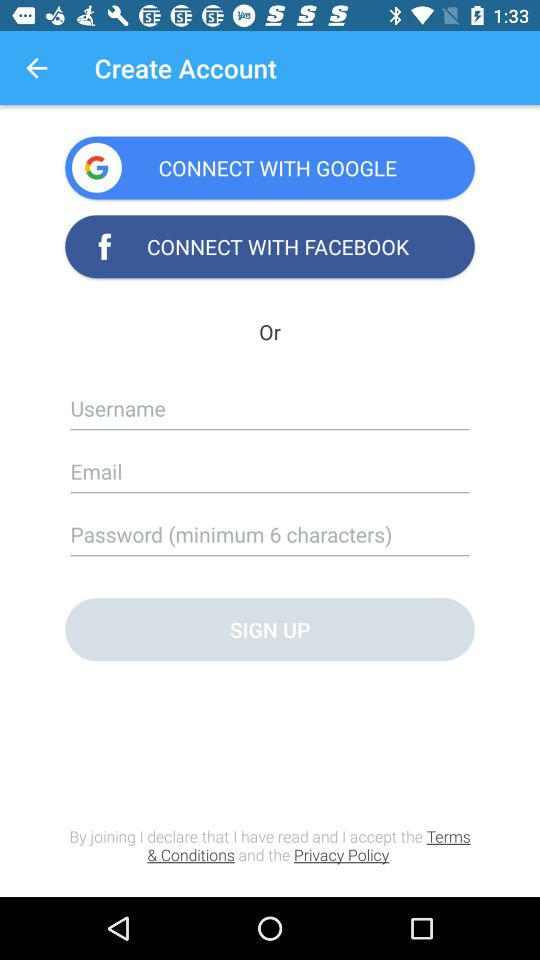How many minimum characters must have been required in the password? The minimum number of characters required in the password is 6. 